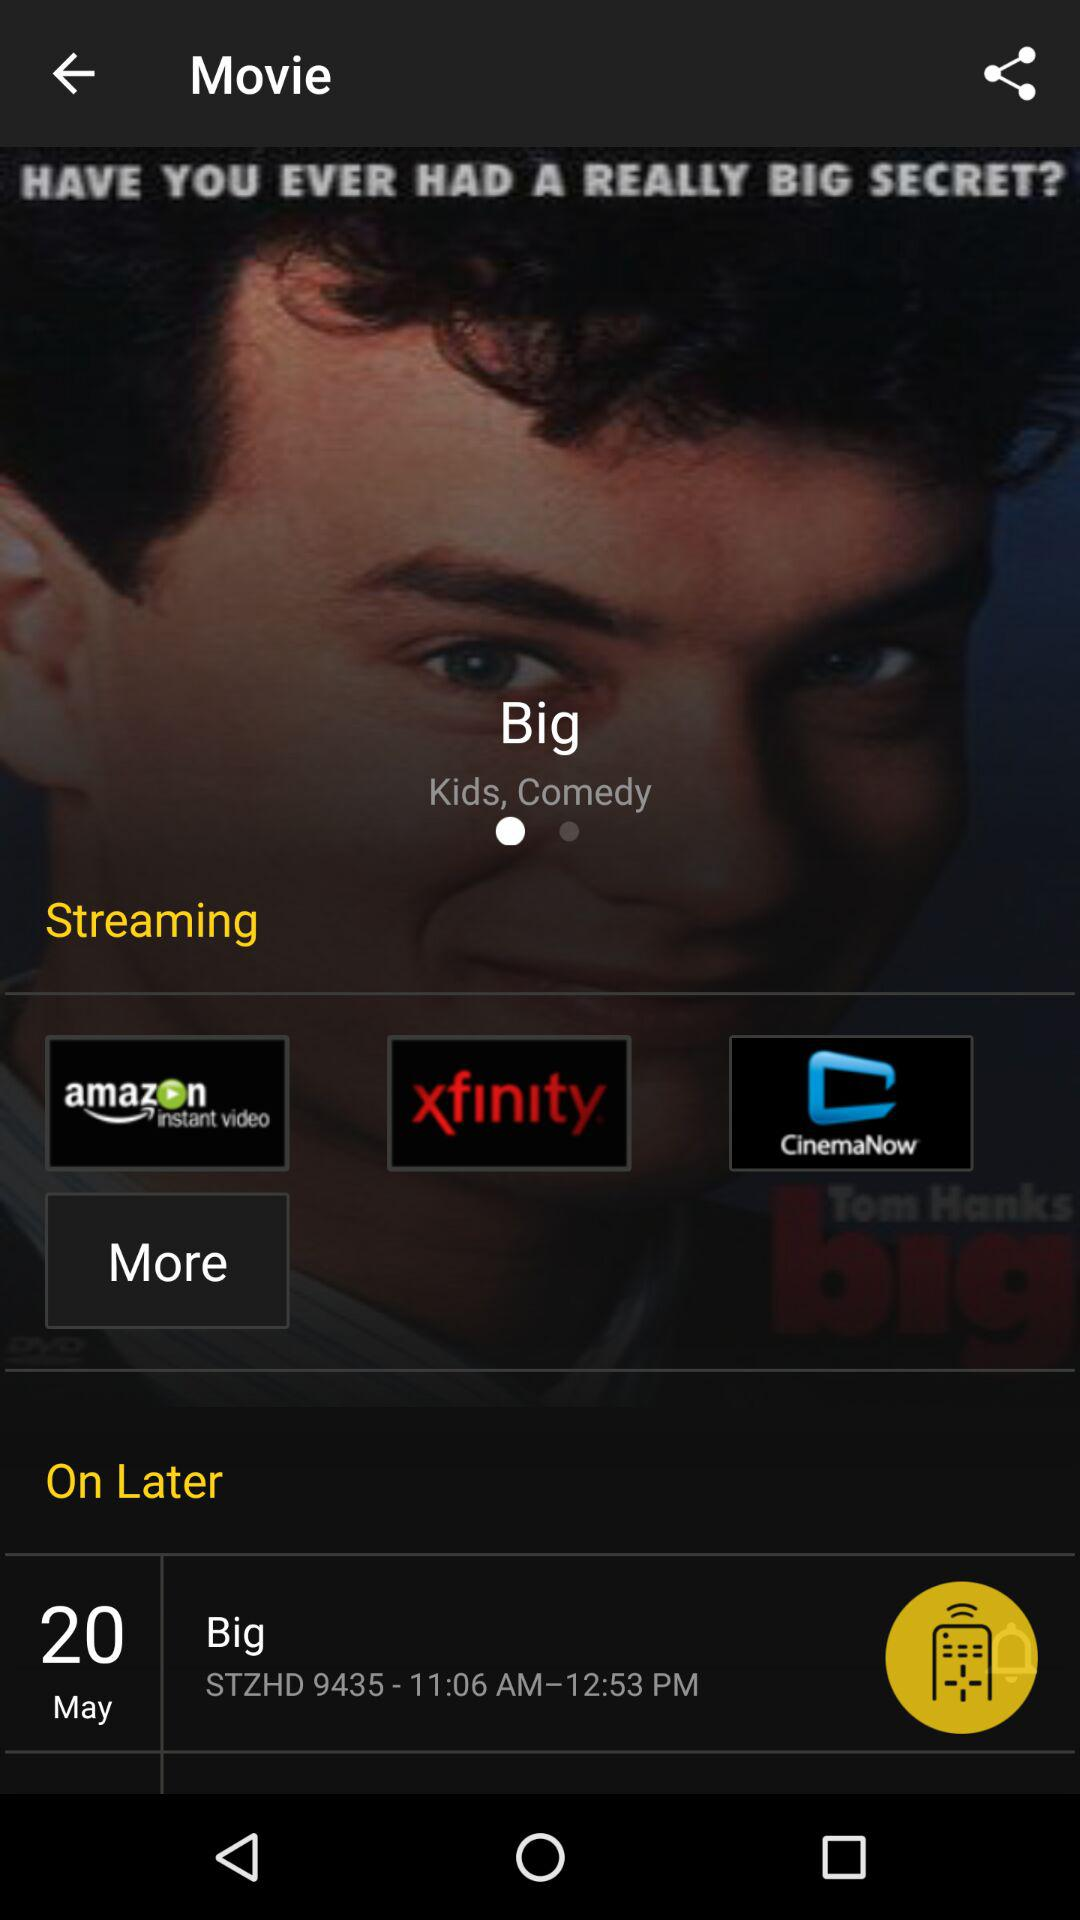On what date will the "Big" movie start? The "Big" movie will start on May 20. 